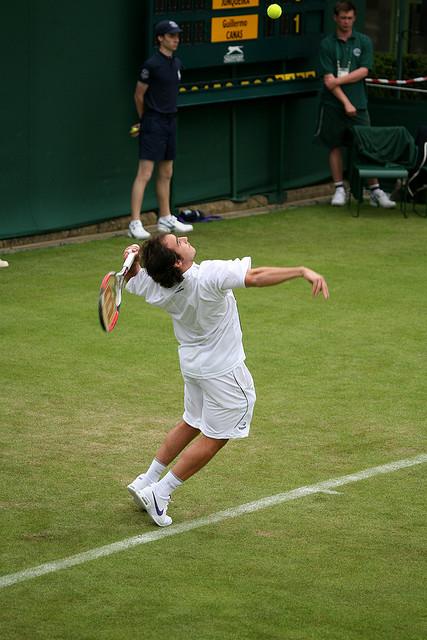Which game is being played?
Quick response, please. Tennis. What color is the man's shirt?
Write a very short answer. White. Who is your favorite tennis player?
Answer briefly. Williams. What brand are the man's shoes?
Keep it brief. Nike. 